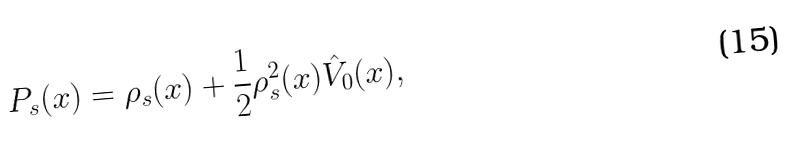Convert formula to latex. <formula><loc_0><loc_0><loc_500><loc_500>P _ { s } ( x ) = \rho _ { s } ( x ) + \frac { 1 } { 2 } \rho _ { s } ^ { 2 } ( x ) \hat { V } _ { 0 } ( x ) ,</formula> 